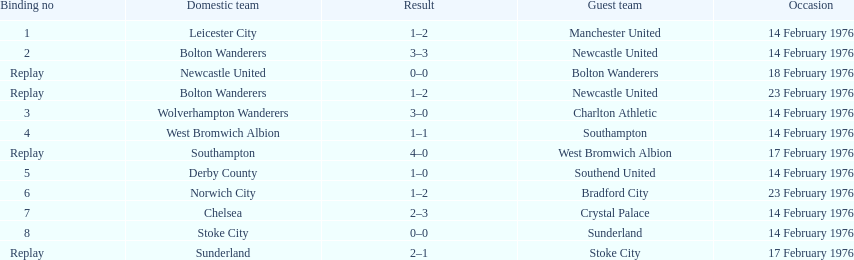How many games played by sunderland are listed here? 2. 